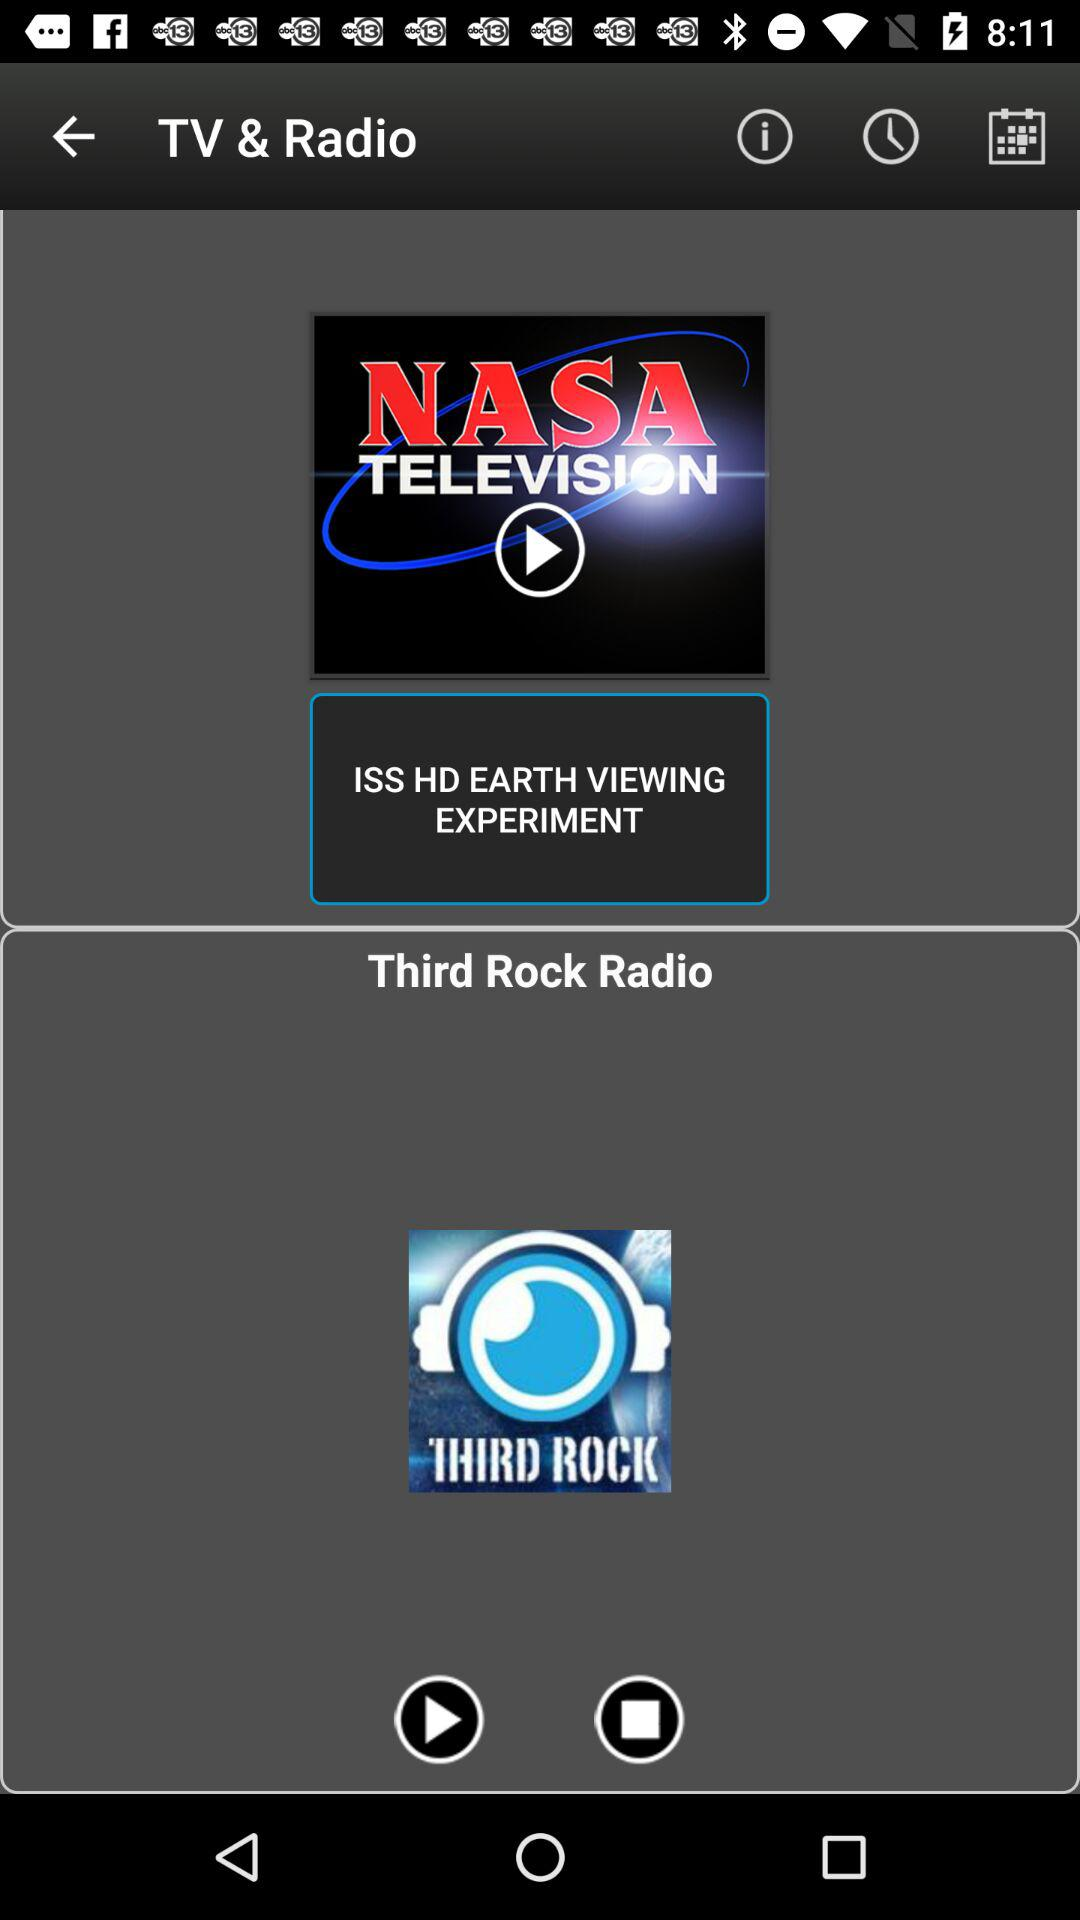How long is the video?
When the provided information is insufficient, respond with <no answer>. <no answer> 